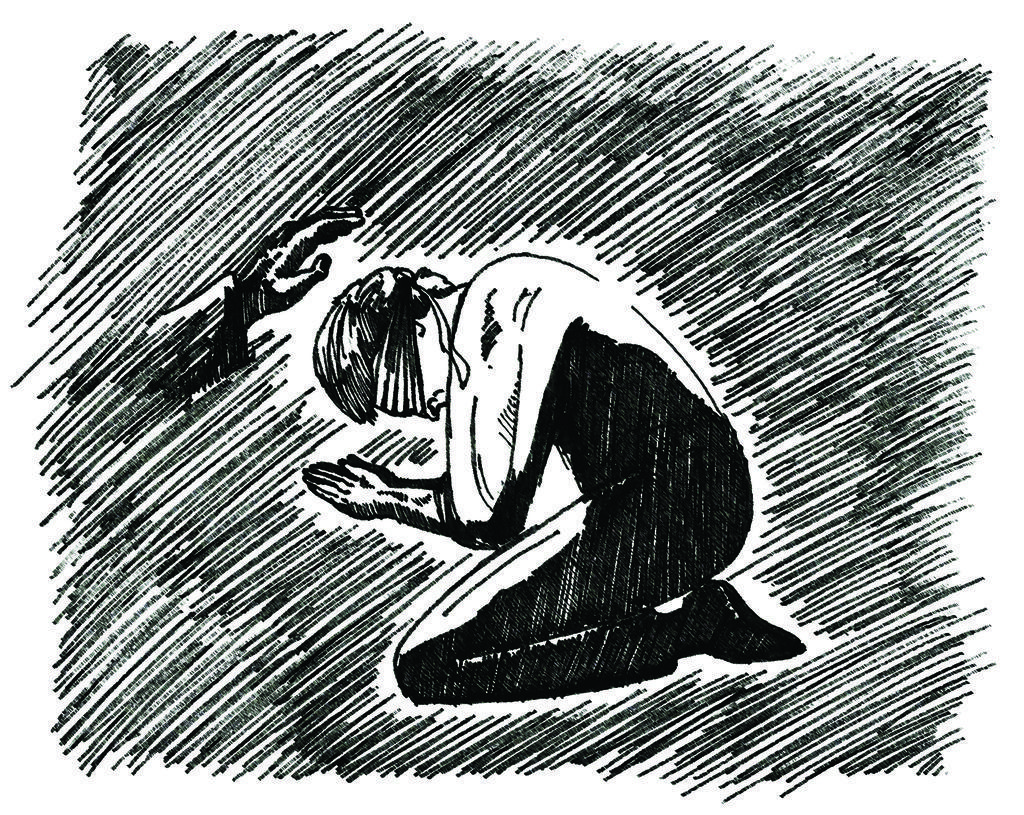Please provide a concise description of this image. There is a drawing in which, there is a person kneeling down and praying to god, in front of a person's hand which is blessing. 